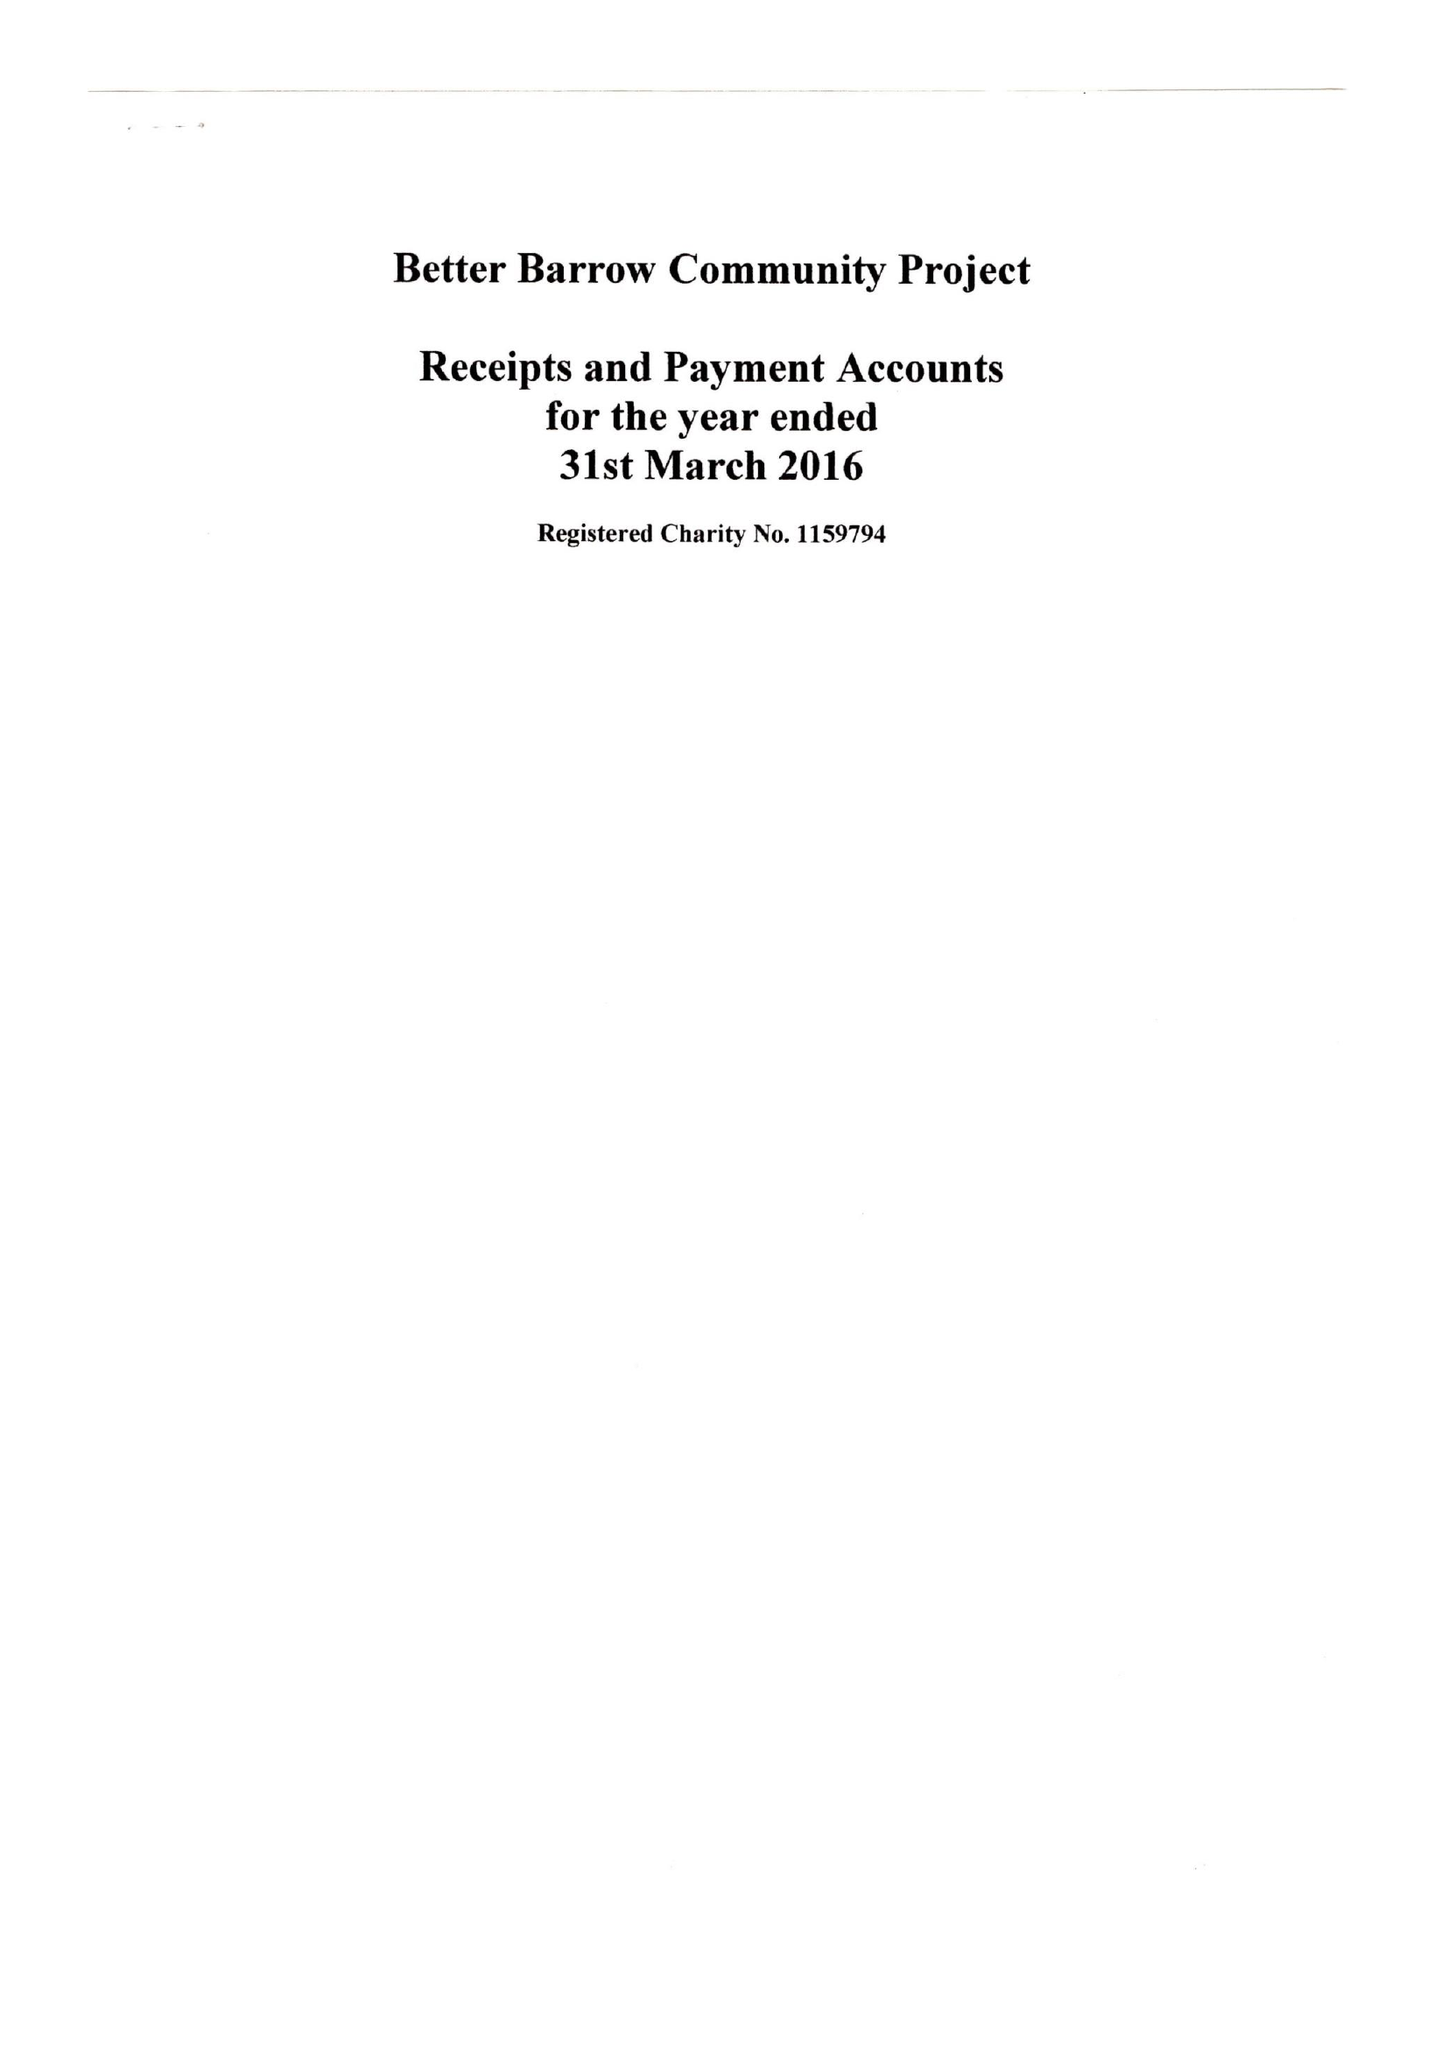What is the value for the address__street_line?
Answer the question using a single word or phrase. HIGH STREET 